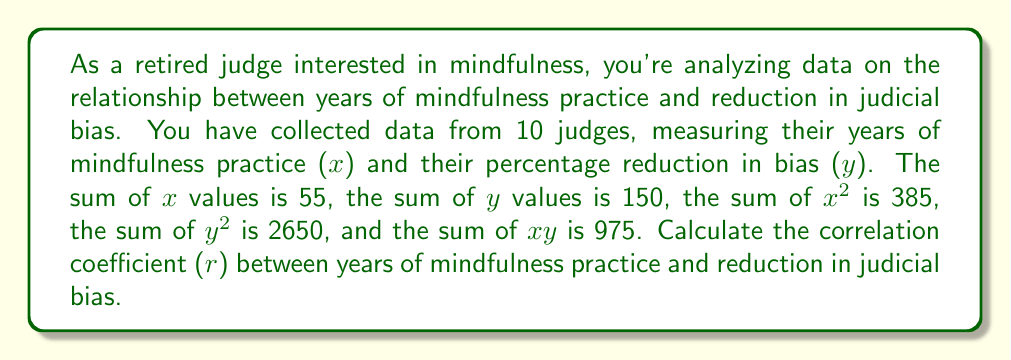Help me with this question. To find the correlation coefficient (r), we'll use the formula:

$$ r = \frac{n\sum xy - \sum x \sum y}{\sqrt{[n\sum x^2 - (\sum x)^2][n\sum y^2 - (\sum y)^2]}} $$

Where:
n = number of data points (10 judges)
Σx = sum of x values (55)
Σy = sum of y values (150)
Σx² = sum of x squared values (385)
Σy² = sum of y squared values (2650)
Σxy = sum of x times y values (975)

Let's substitute these values into the formula:

$$ r = \frac{10(975) - (55)(150)}{\sqrt{[10(385) - (55)^2][10(2650) - (150)^2]}} $$

$$ r = \frac{9750 - 8250}{\sqrt{(3850 - 3025)(26500 - 22500)}} $$

$$ r = \frac{1500}{\sqrt{(825)(4000)}} $$

$$ r = \frac{1500}{\sqrt{3300000}} $$

$$ r = \frac{1500}{1816.59} $$

$$ r \approx 0.8257 $$
Answer: The correlation coefficient (r) between years of mindfulness practice and reduction in judicial bias is approximately 0.8257. 